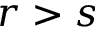Convert formula to latex. <formula><loc_0><loc_0><loc_500><loc_500>r > s</formula> 